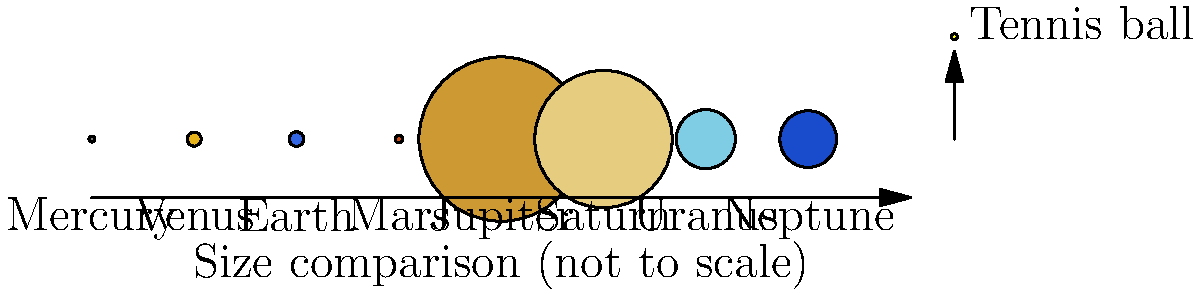If Jupiter were the size of a regulation tennis court (78 feet long), approximately how many tennis balls lined up would represent Earth's diameter? Serve up your best estimate, ace! Let's break this down step-by-step:

1. From the image, we can see that Jupiter's diameter is represented by 28.1 tennis balls, while Earth's is 2.5 tennis balls.

2. We need to set up a proportion:
   Jupiter (in tennis balls) : Jupiter (in feet) = Earth (in tennis balls) : Earth (in feet)

3. We know:
   - Jupiter is 28.1 tennis balls
   - Jupiter is 78 feet (length of a tennis court)
   - Earth is 2.5 tennis balls

4. Let's call Earth's size in feet $x$. We can now set up the equation:
   $\frac{28.1}{78} = \frac{2.5}{x}$

5. Cross multiply:
   $28.1x = 78 * 2.5$

6. Solve for $x$:
   $x = \frac{78 * 2.5}{28.1} \approx 6.94$ feet

7. To convert feet to tennis balls, we need to know the diameter of a tennis ball. A regulation tennis ball is about 2.7 inches in diameter.

8. Convert 6.94 feet to inches:
   $6.94 * 12 \approx 83.28$ inches

9. Divide by the diameter of a tennis ball:
   $83.28 / 2.7 \approx 30.84$ tennis balls

Therefore, Earth would be represented by approximately 31 tennis balls lined up.
Answer: 31 tennis balls 